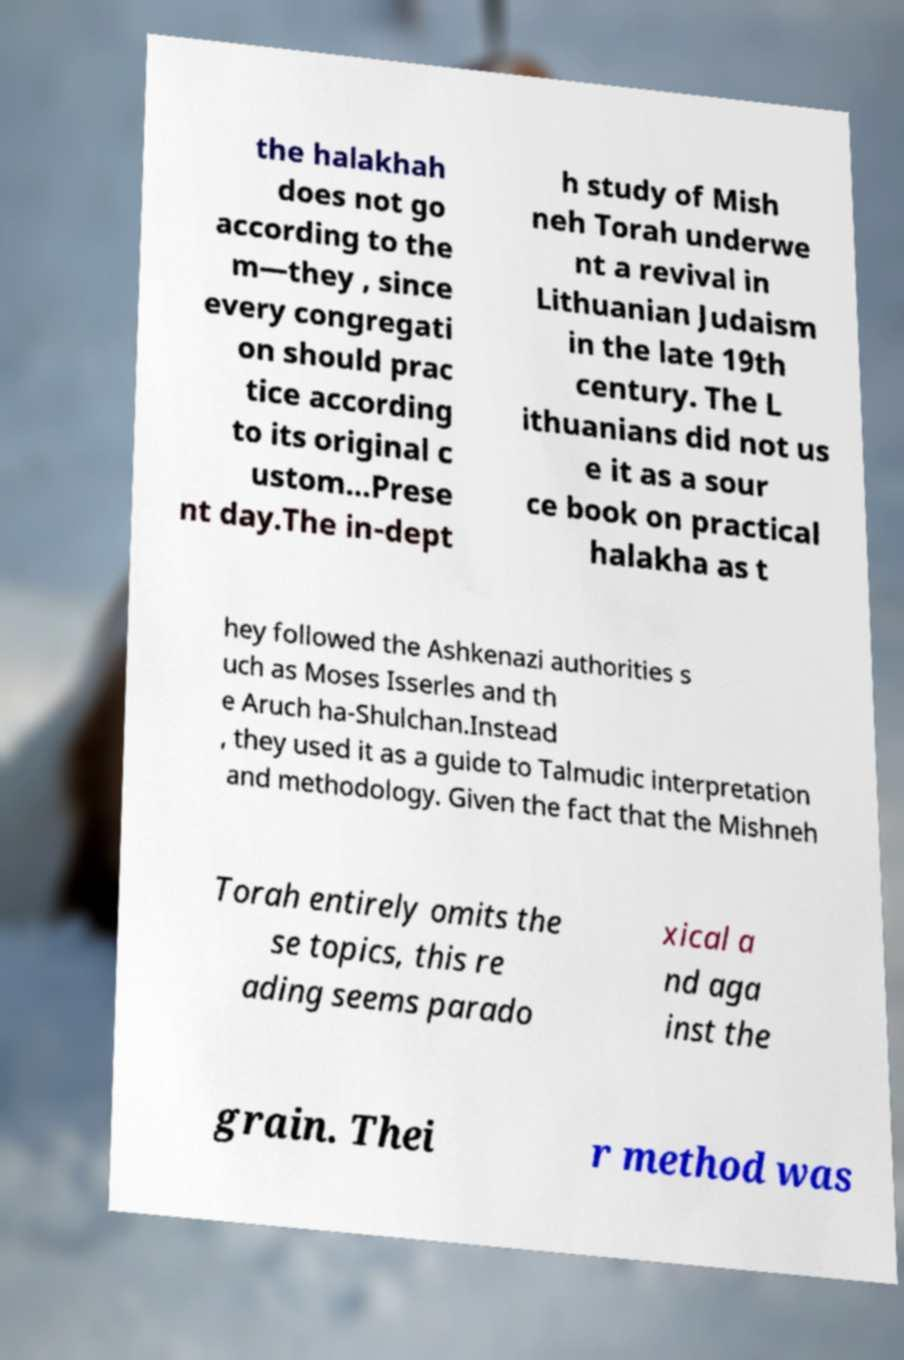There's text embedded in this image that I need extracted. Can you transcribe it verbatim? the halakhah does not go according to the m—they , since every congregati on should prac tice according to its original c ustom…Prese nt day.The in-dept h study of Mish neh Torah underwe nt a revival in Lithuanian Judaism in the late 19th century. The L ithuanians did not us e it as a sour ce book on practical halakha as t hey followed the Ashkenazi authorities s uch as Moses Isserles and th e Aruch ha-Shulchan.Instead , they used it as a guide to Talmudic interpretation and methodology. Given the fact that the Mishneh Torah entirely omits the se topics, this re ading seems parado xical a nd aga inst the grain. Thei r method was 